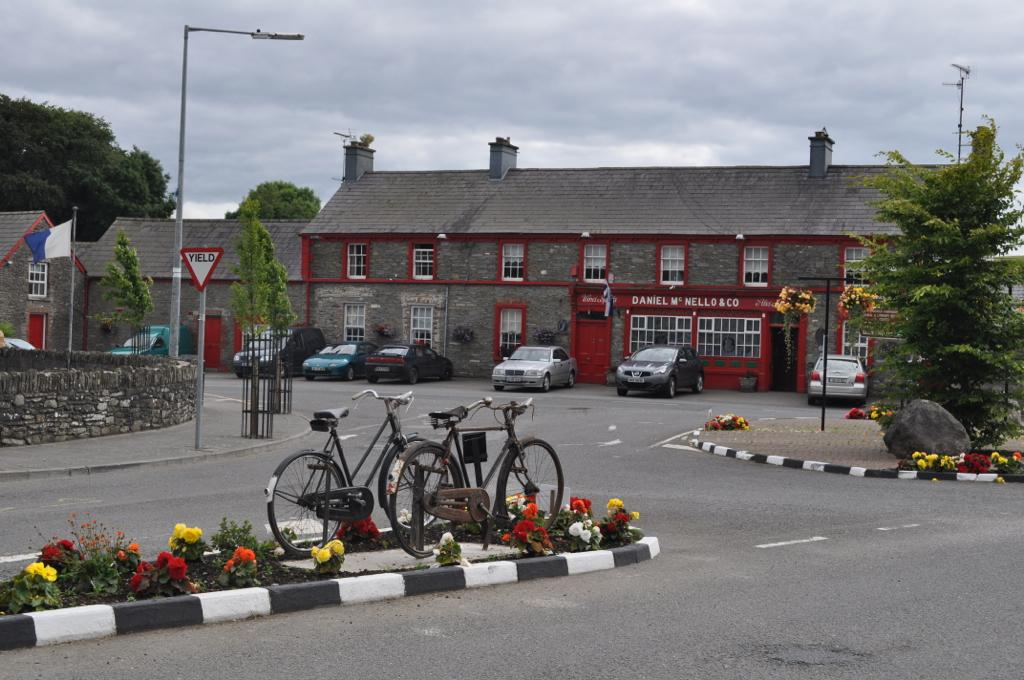What can be seen in the foreground of the image? There are bicycles and flower plants in the foreground of the image. What is visible in the background of the image? There are houses, trees, poles, a flag, and the sky in the background of the image. How many types of structures are visible in the background? There are two types of structures visible in the background: houses and poles. What natural elements can be seen in the image? Trees and the sky are natural elements visible in the image. What type of desk can be seen in the image? There is no desk present in the image. How many stars are visible in the image? There are no stars visible in the image. 